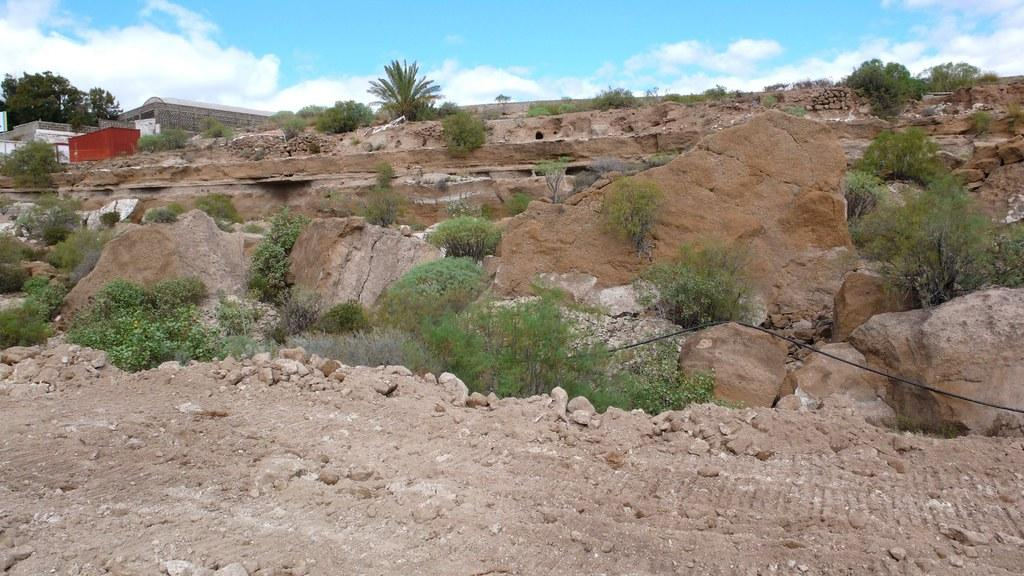What is located in the middle of the image? In the middle of the image, there are stones, plants, grass, trees, houses, land, sky, and clouds. Can you describe the natural elements present in the middle of the image? The natural elements in the middle of the image include plants, grass, trees, land, sky, and clouds. How many types of structures can be seen in the middle of the image? There is one type of structure visible in the middle of the image, which are houses. What type of agreement can be seen being signed in the image? There is no agreement being signed in the image; it features a variety of elements in the middle of the image. What sound can be heard coming from the trees in the image? There is no sound present in the image, as it is a still image. 